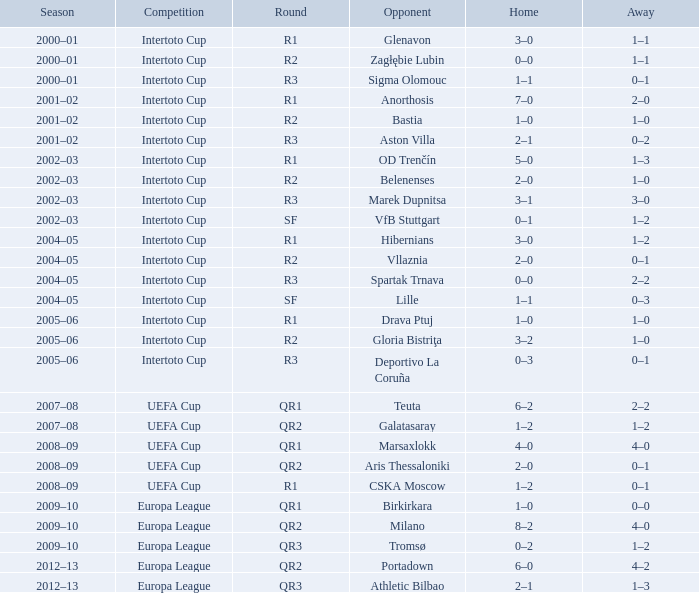Parse the full table. {'header': ['Season', 'Competition', 'Round', 'Opponent', 'Home', 'Away'], 'rows': [['2000–01', 'Intertoto Cup', 'R1', 'Glenavon', '3–0', '1–1'], ['2000–01', 'Intertoto Cup', 'R2', 'Zagłębie Lubin', '0–0', '1–1'], ['2000–01', 'Intertoto Cup', 'R3', 'Sigma Olomouc', '1–1', '0–1'], ['2001–02', 'Intertoto Cup', 'R1', 'Anorthosis', '7–0', '2–0'], ['2001–02', 'Intertoto Cup', 'R2', 'Bastia', '1–0', '1–0'], ['2001–02', 'Intertoto Cup', 'R3', 'Aston Villa', '2–1', '0–2'], ['2002–03', 'Intertoto Cup', 'R1', 'OD Trenčín', '5–0', '1–3'], ['2002–03', 'Intertoto Cup', 'R2', 'Belenenses', '2–0', '1–0'], ['2002–03', 'Intertoto Cup', 'R3', 'Marek Dupnitsa', '3–1', '3–0'], ['2002–03', 'Intertoto Cup', 'SF', 'VfB Stuttgart', '0–1', '1–2'], ['2004–05', 'Intertoto Cup', 'R1', 'Hibernians', '3–0', '1–2'], ['2004–05', 'Intertoto Cup', 'R2', 'Vllaznia', '2–0', '0–1'], ['2004–05', 'Intertoto Cup', 'R3', 'Spartak Trnava', '0–0', '2–2'], ['2004–05', 'Intertoto Cup', 'SF', 'Lille', '1–1', '0–3'], ['2005–06', 'Intertoto Cup', 'R1', 'Drava Ptuj', '1–0', '1–0'], ['2005–06', 'Intertoto Cup', 'R2', 'Gloria Bistriţa', '3–2', '1–0'], ['2005–06', 'Intertoto Cup', 'R3', 'Deportivo La Coruña', '0–3', '0–1'], ['2007–08', 'UEFA Cup', 'QR1', 'Teuta', '6–2', '2–2'], ['2007–08', 'UEFA Cup', 'QR2', 'Galatasaray', '1–2', '1–2'], ['2008–09', 'UEFA Cup', 'QR1', 'Marsaxlokk', '4–0', '4–0'], ['2008–09', 'UEFA Cup', 'QR2', 'Aris Thessaloniki', '2–0', '0–1'], ['2008–09', 'UEFA Cup', 'R1', 'CSKA Moscow', '1–2', '0–1'], ['2009–10', 'Europa League', 'QR1', 'Birkirkara', '1–0', '0–0'], ['2009–10', 'Europa League', 'QR2', 'Milano', '8–2', '4–0'], ['2009–10', 'Europa League', 'QR3', 'Tromsø', '0–2', '1–2'], ['2012–13', 'Europa League', 'QR2', 'Portadown', '6–0', '4–2'], ['2012–13', 'Europa League', 'QR3', 'Athletic Bilbao', '2–1', '1–3']]} What is the home score when facing marek dupnitsa as an adversary? 3–1. 